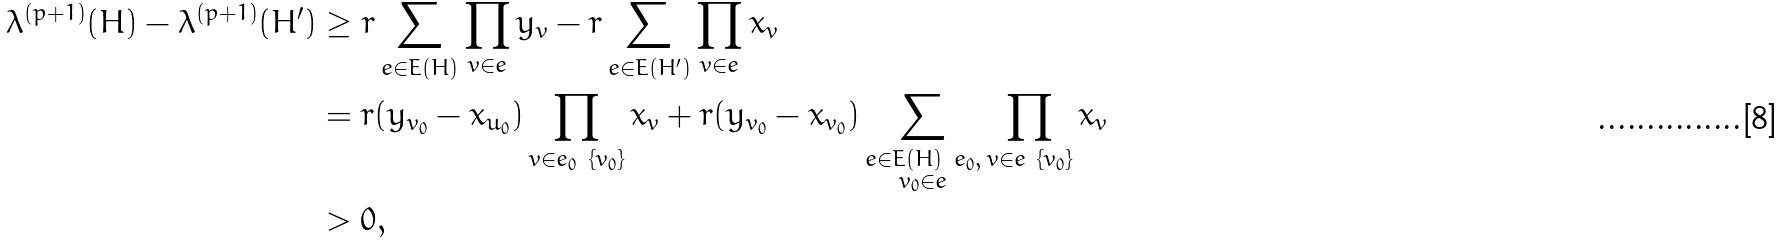<formula> <loc_0><loc_0><loc_500><loc_500>\lambda ^ { ( p + 1 ) } ( H ) - \lambda ^ { ( p + 1 ) } ( H ^ { \prime } ) & \geq r \sum _ { e \in E ( H ) } \prod _ { v \in e } y _ { v } - r \sum _ { e \in E ( H ^ { \prime } ) } \prod _ { v \in e } x _ { v } \\ & = r ( y _ { v _ { 0 } } - x _ { u _ { 0 } } ) \prod _ { v \in e _ { 0 } \ \{ v _ { 0 } \} } x _ { v } + r ( y _ { v _ { 0 } } - x _ { v _ { 0 } } ) \sum _ { \substack { e \in E ( H ) \ e _ { 0 } , \\ v _ { 0 } \in e } } \prod _ { v \in e \ \{ v _ { 0 } \} } x _ { v } \\ & > 0 ,</formula> 